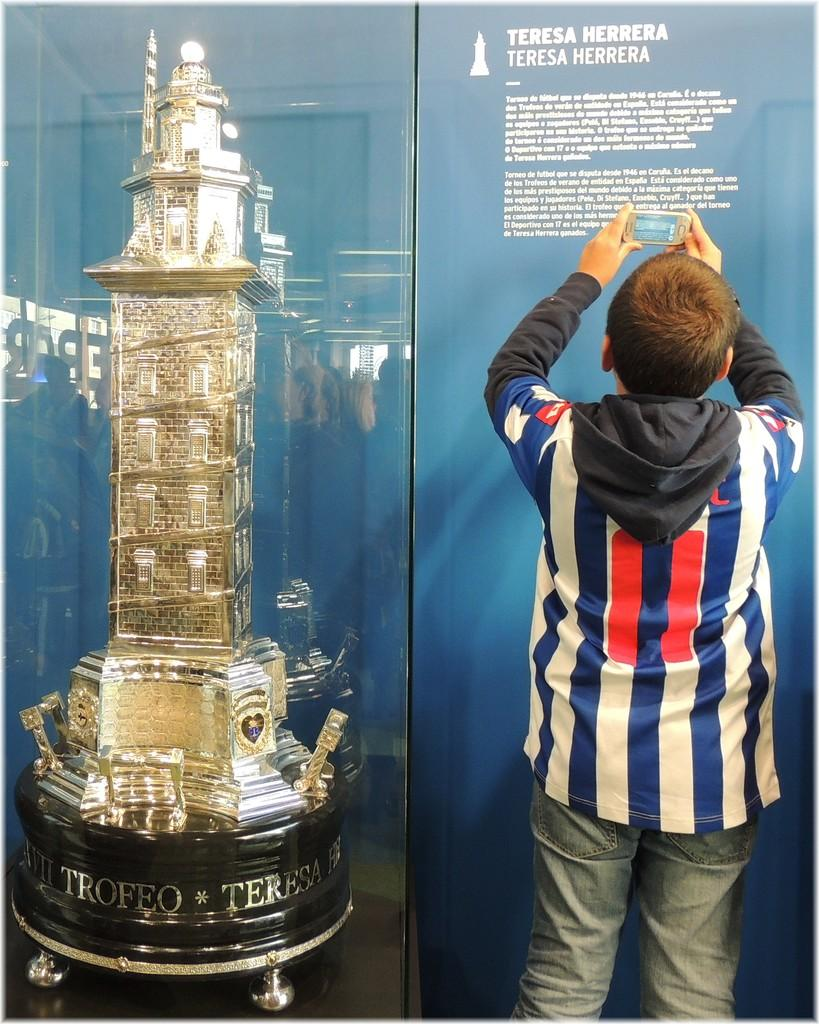<image>
Share a concise interpretation of the image provided. A work by Teresa Herrera is displayed behind glass against a blue wall. 